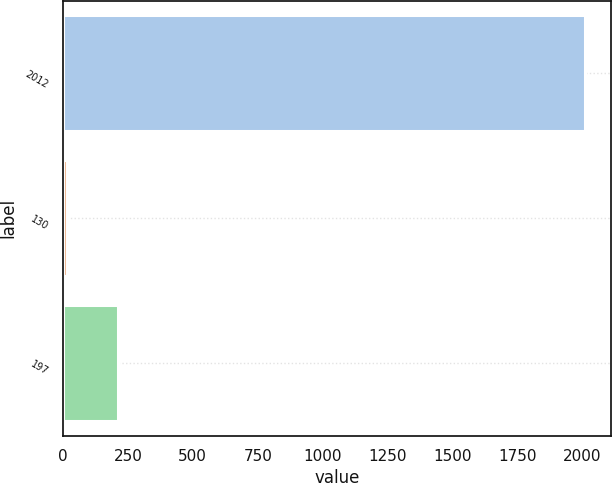<chart> <loc_0><loc_0><loc_500><loc_500><bar_chart><fcel>2012<fcel>130<fcel>197<nl><fcel>2011<fcel>13.7<fcel>213.43<nl></chart> 